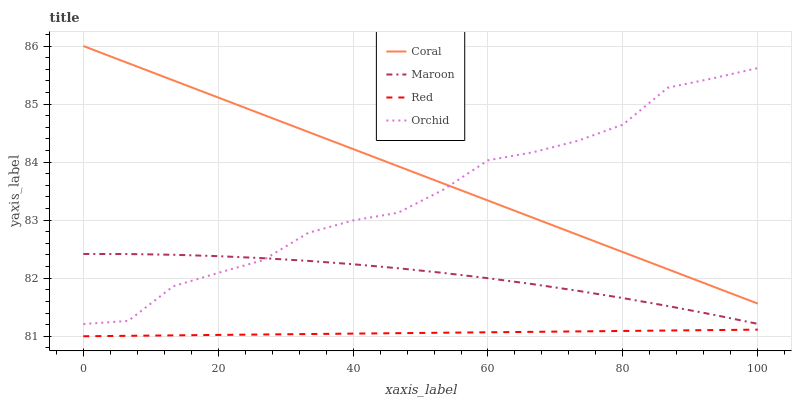Does Red have the minimum area under the curve?
Answer yes or no. Yes. Does Coral have the maximum area under the curve?
Answer yes or no. Yes. Does Maroon have the minimum area under the curve?
Answer yes or no. No. Does Maroon have the maximum area under the curve?
Answer yes or no. No. Is Coral the smoothest?
Answer yes or no. Yes. Is Orchid the roughest?
Answer yes or no. Yes. Is Red the smoothest?
Answer yes or no. No. Is Red the roughest?
Answer yes or no. No. Does Red have the lowest value?
Answer yes or no. Yes. Does Maroon have the lowest value?
Answer yes or no. No. Does Coral have the highest value?
Answer yes or no. Yes. Does Maroon have the highest value?
Answer yes or no. No. Is Maroon less than Coral?
Answer yes or no. Yes. Is Orchid greater than Red?
Answer yes or no. Yes. Does Coral intersect Orchid?
Answer yes or no. Yes. Is Coral less than Orchid?
Answer yes or no. No. Is Coral greater than Orchid?
Answer yes or no. No. Does Maroon intersect Coral?
Answer yes or no. No. 